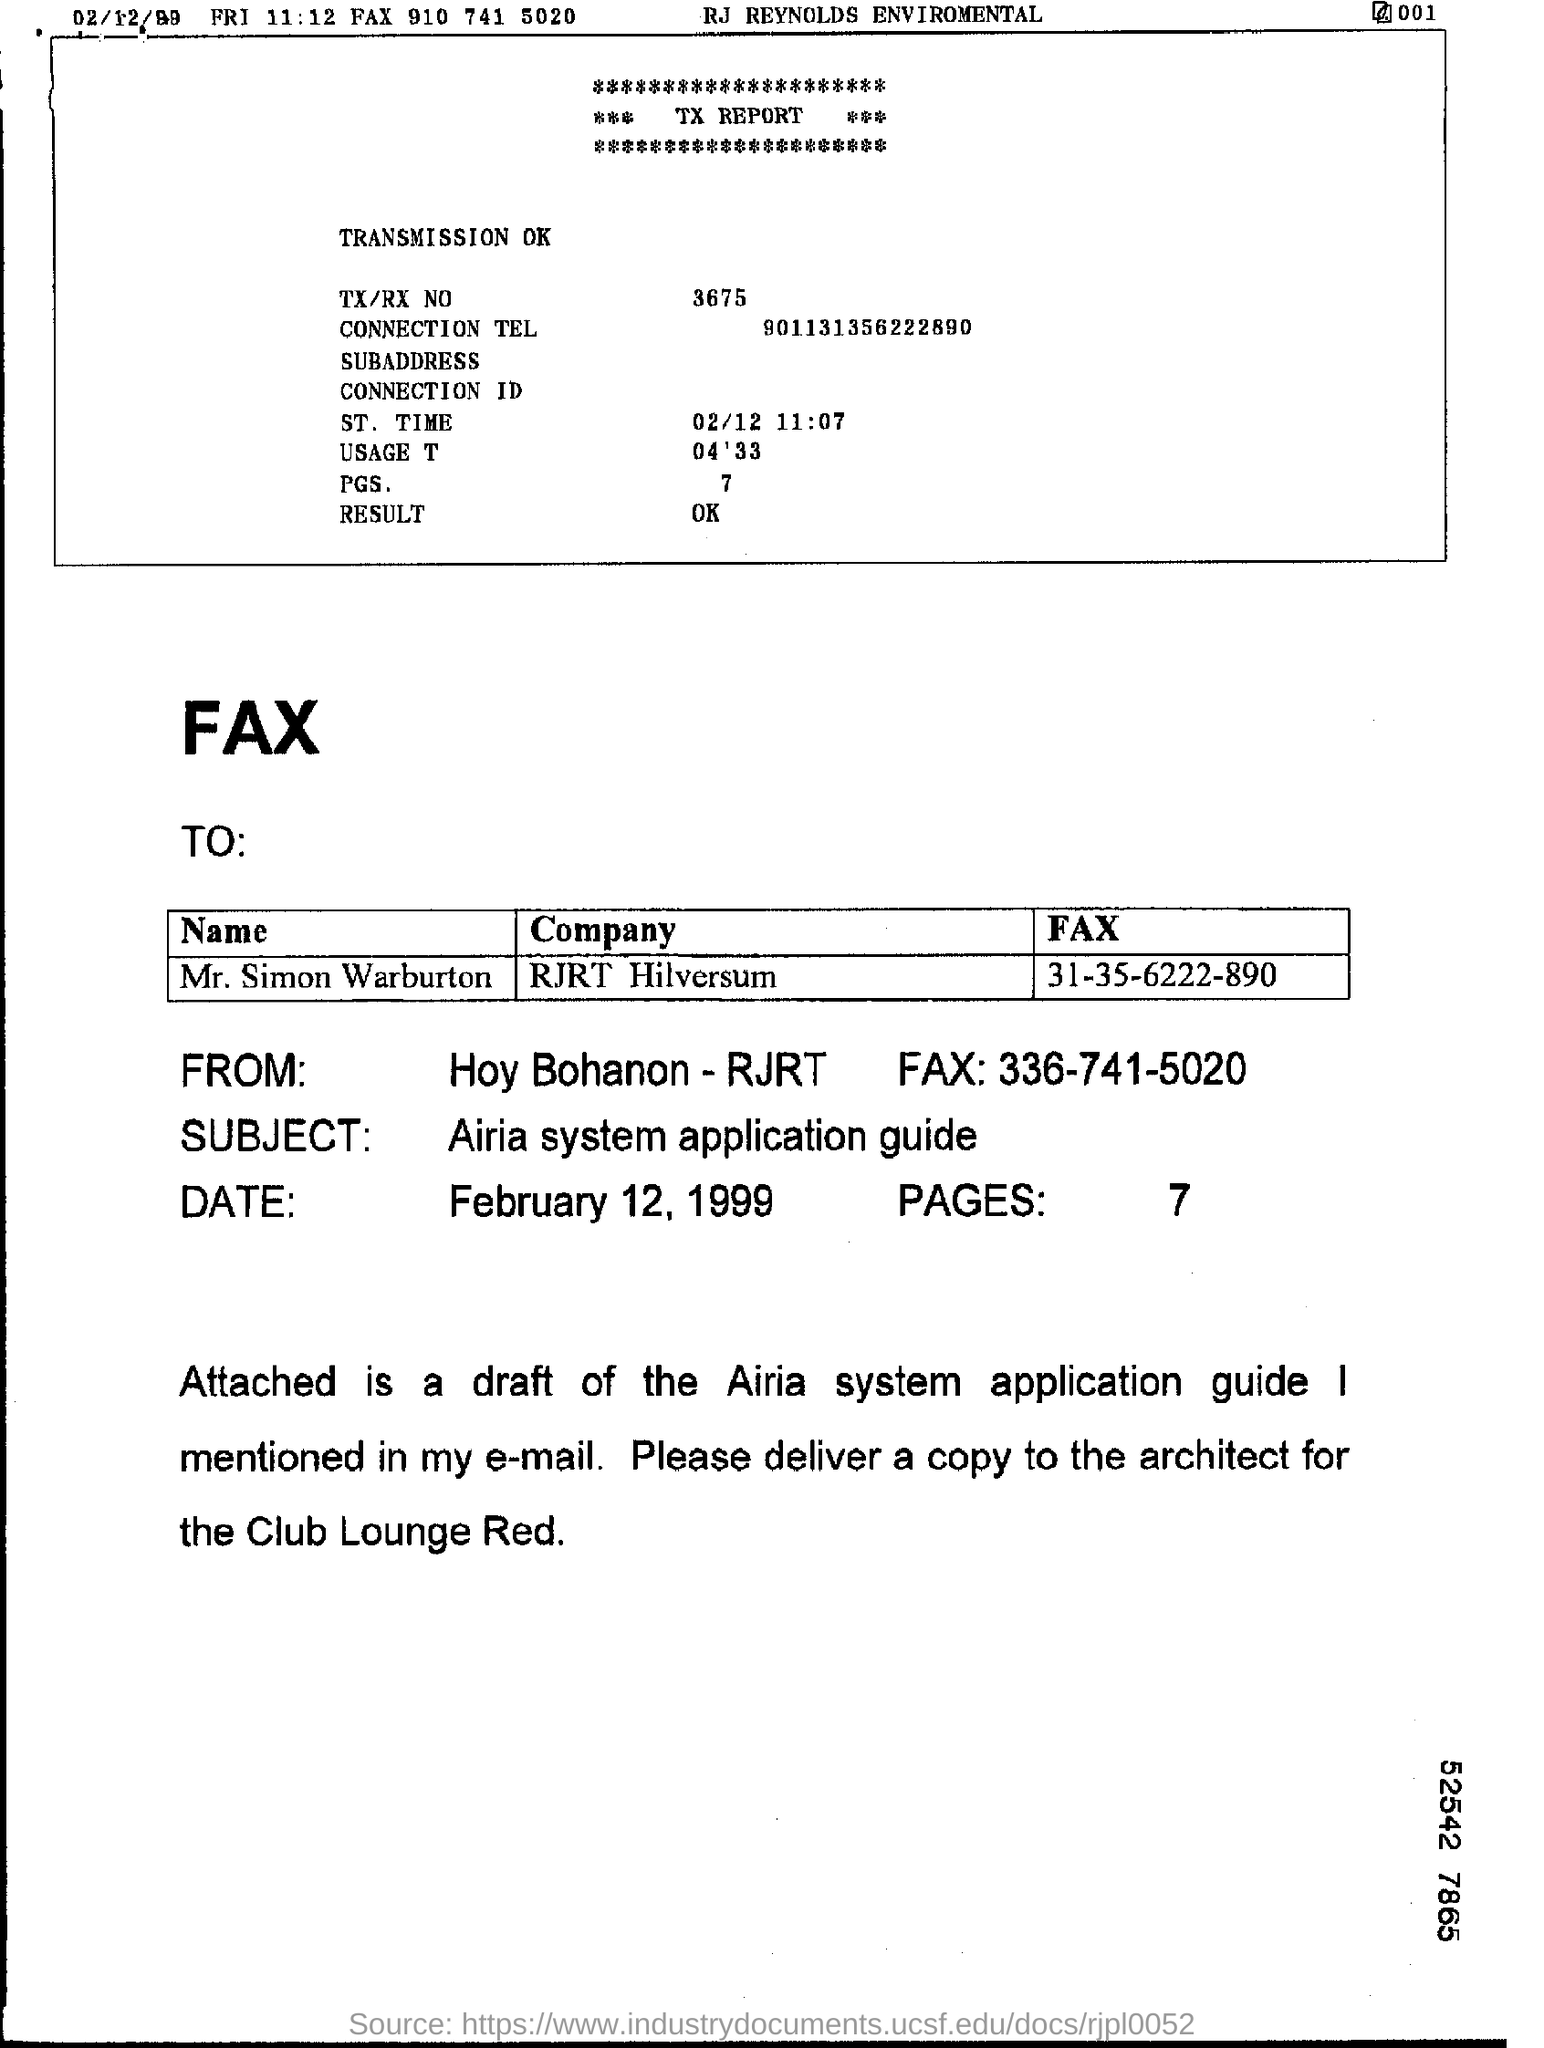Give some essential details in this illustration. The time mentioned in the transaction report is 02/12 at 11:07. The fax was written to the company RJRT Hilversum. The subject mentioned in the fax is the Airia system application guide. The usage time reported in the TX report is 04'33"... The TX/RX NO mentioned in the TX REPORT is 3675. 